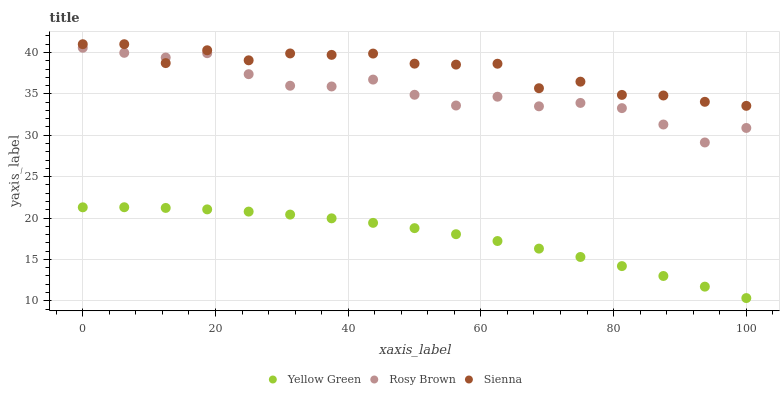Does Yellow Green have the minimum area under the curve?
Answer yes or no. Yes. Does Sienna have the maximum area under the curve?
Answer yes or no. Yes. Does Rosy Brown have the minimum area under the curve?
Answer yes or no. No. Does Rosy Brown have the maximum area under the curve?
Answer yes or no. No. Is Yellow Green the smoothest?
Answer yes or no. Yes. Is Sienna the roughest?
Answer yes or no. Yes. Is Rosy Brown the smoothest?
Answer yes or no. No. Is Rosy Brown the roughest?
Answer yes or no. No. Does Yellow Green have the lowest value?
Answer yes or no. Yes. Does Rosy Brown have the lowest value?
Answer yes or no. No. Does Sienna have the highest value?
Answer yes or no. Yes. Does Rosy Brown have the highest value?
Answer yes or no. No. Is Yellow Green less than Rosy Brown?
Answer yes or no. Yes. Is Sienna greater than Yellow Green?
Answer yes or no. Yes. Does Sienna intersect Rosy Brown?
Answer yes or no. Yes. Is Sienna less than Rosy Brown?
Answer yes or no. No. Is Sienna greater than Rosy Brown?
Answer yes or no. No. Does Yellow Green intersect Rosy Brown?
Answer yes or no. No. 